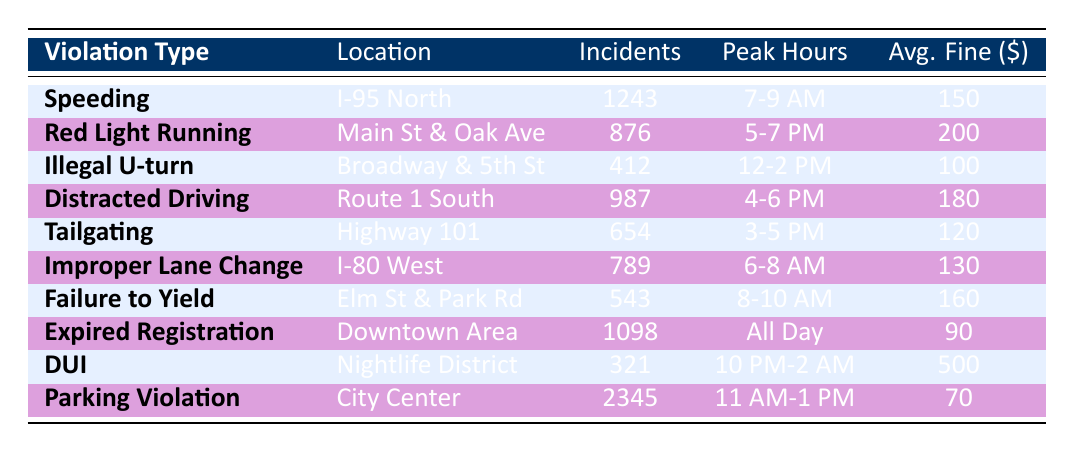What is the highest number of incidents recorded for a single violation type? The "Parking Violation" has the highest number of incidents at 2345 as recorded in the table. I checked the "Number of Incidents" column for each violation type and found that 2345 was the greatest value.
Answer: 2345 Which violation type has the highest average fine? In the table, the "DUI" violation type has the highest average fine at 500 dollars. By comparing the "Average Fine" column, I confirmed that 500 is greater than all other values listed.
Answer: 500 How many total incidents were recorded for "Speeding" and "Distracted Driving"? The incidents for "Speeding" are 1243 and for "Distracted Driving" are 987. Adding these together gives 1243 + 987 = 2230 total incidents.
Answer: 2230 Is the peak hour for "Red Light Running" the same as the peak hour for "Failure to Yield"? The peak hour for "Red Light Running" is from 5-7 PM, while "Failure to Yield" is from 8-10 AM. Since these times are different, the answer is no.
Answer: No What is the average fine for violations occurring between 6 AM and 8 AM? The applicable violations during this time are "Improper Lane Change" with an average fine of 130 dollars. The average fine in this case is thus 130 since there is only one violation type.
Answer: 130 How many incidents are recorded for "Expired Registration" compared to the sum of incidents for "Illegal U-turn" and "DUI"? "Expired Registration" has 1098 incidents. "Illegal U-turn" has 412 incidents and "DUI" has 321 incidents, adding these gives 412 + 321 = 733. Comparing these gives 1098 (Expired Registration) is greater than 733 (sum of Illegal U-turn and DUI).
Answer: 1098 is greater What is the combined average fine for "Tailgating" and "Improper Lane Change"? The average fine for "Tailgating" is 120 and for "Improper Lane Change" is 130. Adding these gives 120 + 130 = 250. To find the combined average for these two violation types, divide by 2: 250/2 = 125.
Answer: 125 Which violation type has incidents reported at all hours of the day? According to the table, "Expired Registration" is reported to occur "All Day," indicating that it has incidents recorded at any time. I verified other violation types, and none indicated 24-hour incidents.
Answer: Expired Registration How many more incidents does "Parking Violation" have than "DUI"? "Parking Violation" has 2345 incidents, while "DUI" has 321 incidents. Subtracting gives 2345 - 321 = 2024 more incidents for Parking Violation than DUI.
Answer: 2024 